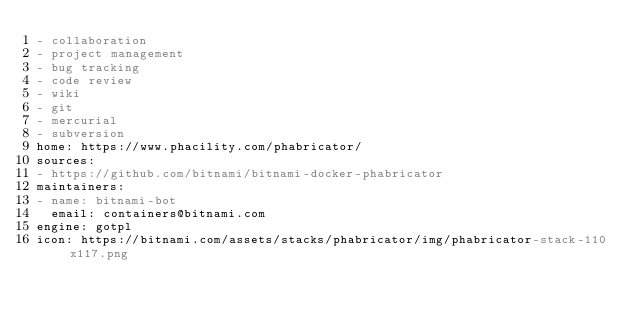<code> <loc_0><loc_0><loc_500><loc_500><_YAML_>- collaboration
- project management
- bug tracking
- code review
- wiki
- git
- mercurial
- subversion
home: https://www.phacility.com/phabricator/
sources:
- https://github.com/bitnami/bitnami-docker-phabricator
maintainers:
- name: bitnami-bot
  email: containers@bitnami.com
engine: gotpl
icon: https://bitnami.com/assets/stacks/phabricator/img/phabricator-stack-110x117.png
</code> 